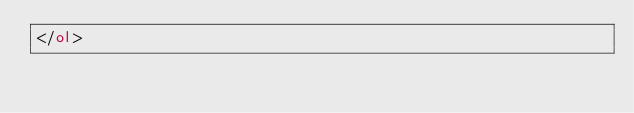Convert code to text. <code><loc_0><loc_0><loc_500><loc_500><_HTML_></ol>
</code> 